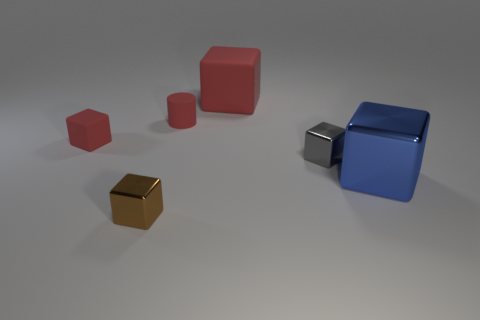Are there any reflections on the objects that provide clues about the environment outside the frame? The reflective surfaces on the objects, particularly on the metallic cylinder and the larger cubes, display muted reflections with no definitive shapes, suggesting an environment with limited or no distinct surrounding features, possibly indicating a controlled studio setting. 